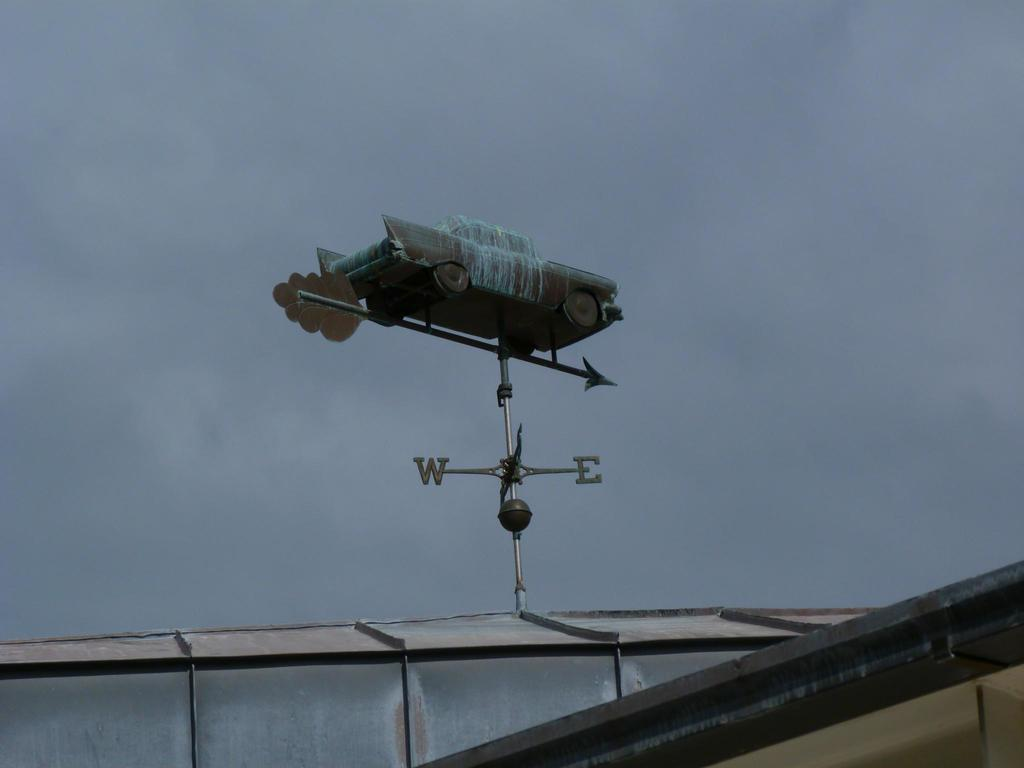<image>
Provide a brief description of the given image. An ersatz weather vane with W and E directionals has a car on top. 